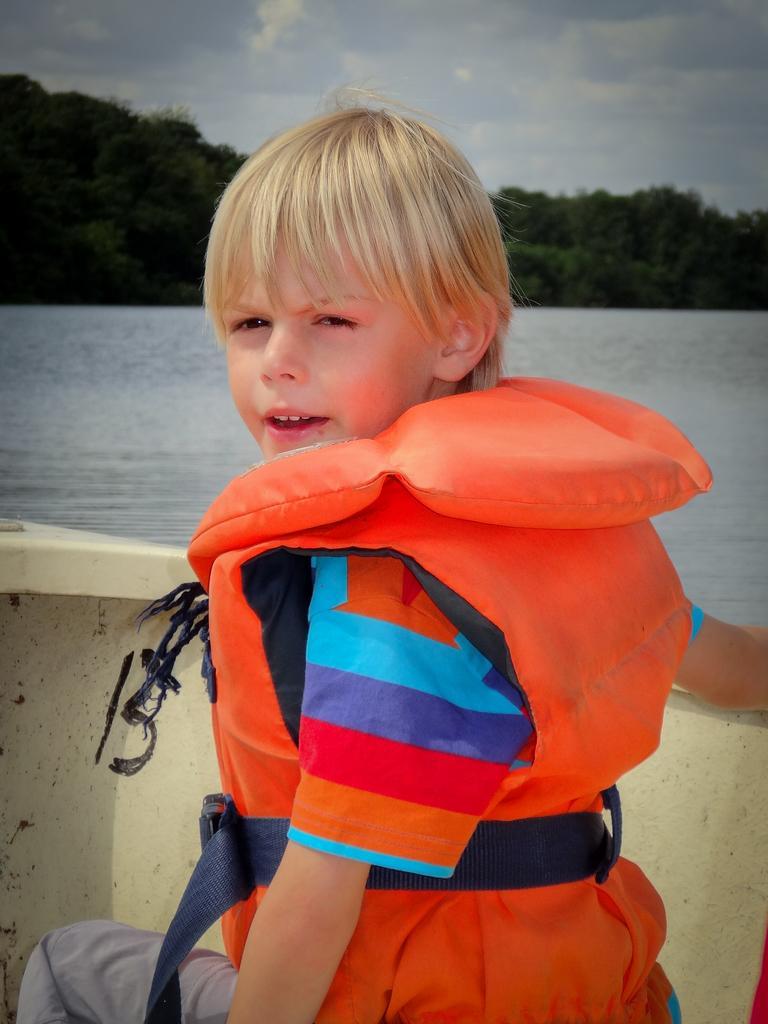Can you describe this image briefly? In the image we can see a boy and life jacket. He is sitting in the boat. Here we can see water, trees and the cloudy sky. 